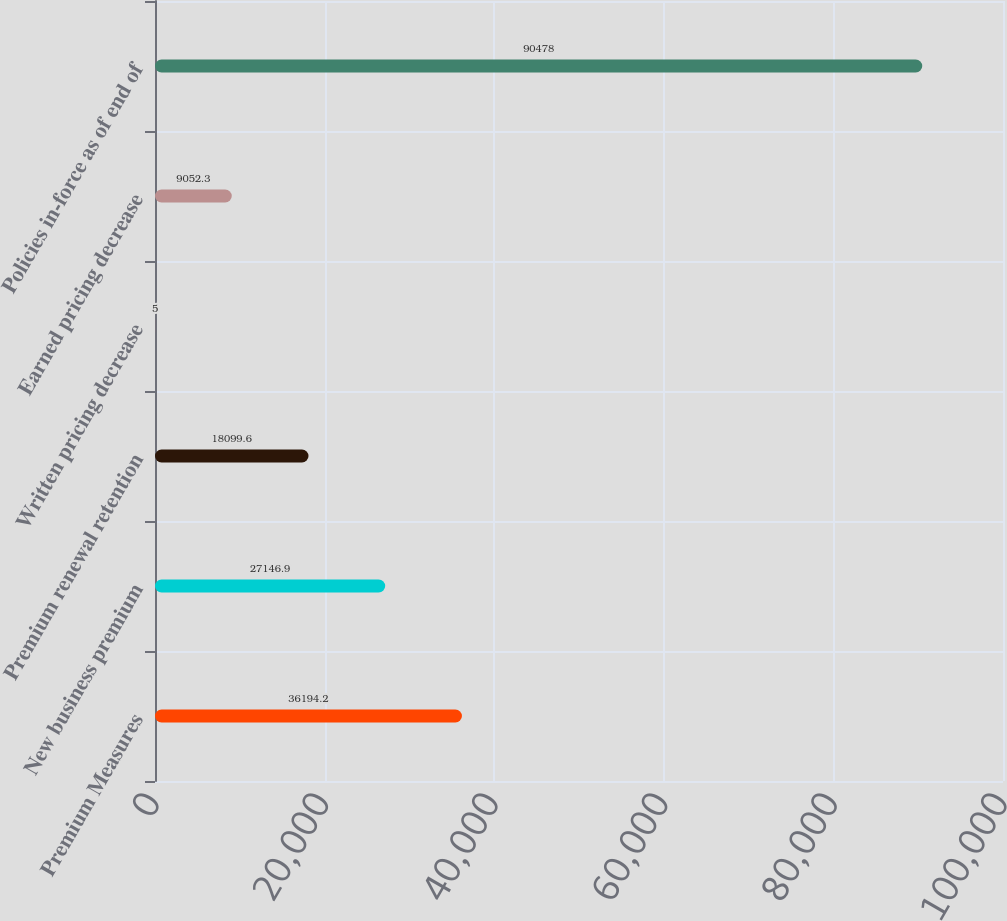Convert chart to OTSL. <chart><loc_0><loc_0><loc_500><loc_500><bar_chart><fcel>Premium Measures<fcel>New business premium<fcel>Premium renewal retention<fcel>Written pricing decrease<fcel>Earned pricing decrease<fcel>Policies in-force as of end of<nl><fcel>36194.2<fcel>27146.9<fcel>18099.6<fcel>5<fcel>9052.3<fcel>90478<nl></chart> 